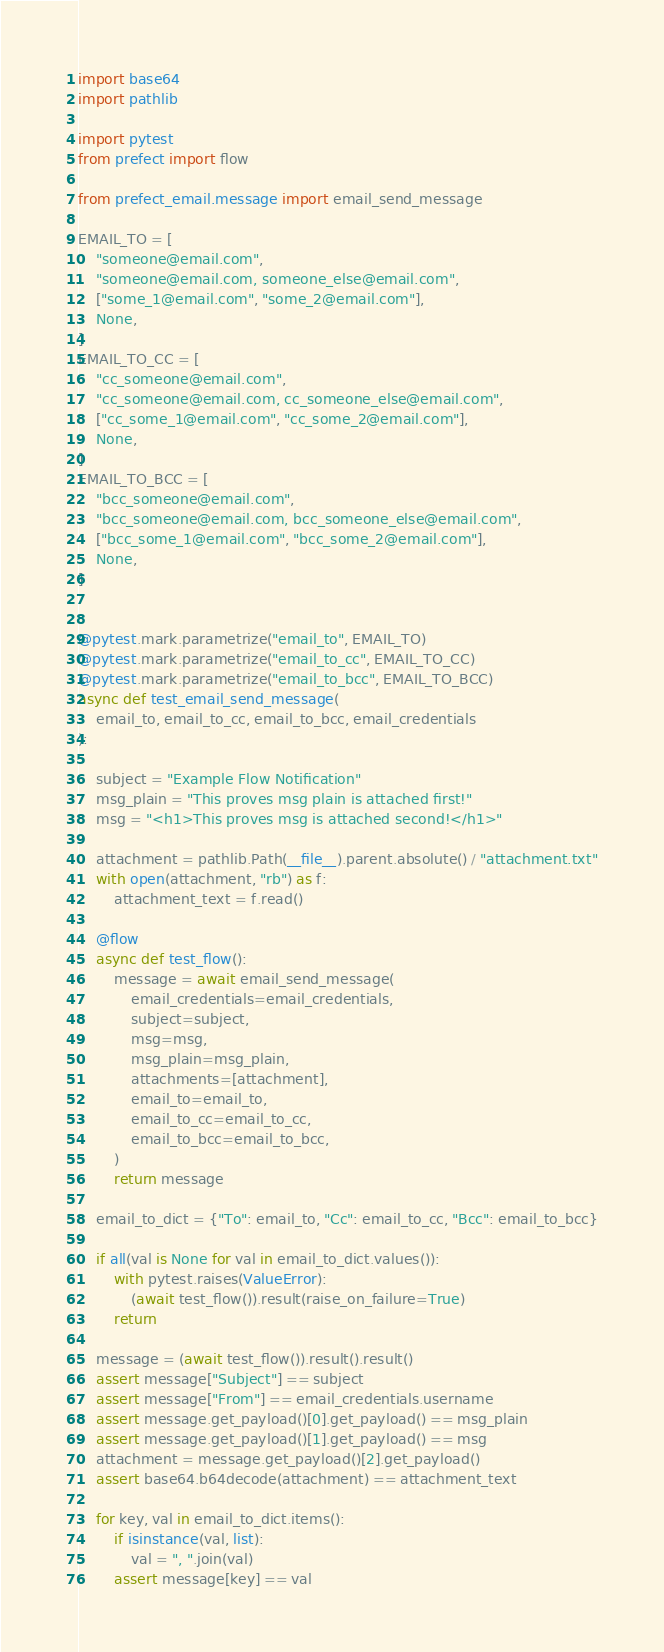Convert code to text. <code><loc_0><loc_0><loc_500><loc_500><_Python_>import base64
import pathlib

import pytest
from prefect import flow

from prefect_email.message import email_send_message

EMAIL_TO = [
    "someone@email.com",
    "someone@email.com, someone_else@email.com",
    ["some_1@email.com", "some_2@email.com"],
    None,
]
EMAIL_TO_CC = [
    "cc_someone@email.com",
    "cc_someone@email.com, cc_someone_else@email.com",
    ["cc_some_1@email.com", "cc_some_2@email.com"],
    None,
]
EMAIL_TO_BCC = [
    "bcc_someone@email.com",
    "bcc_someone@email.com, bcc_someone_else@email.com",
    ["bcc_some_1@email.com", "bcc_some_2@email.com"],
    None,
]


@pytest.mark.parametrize("email_to", EMAIL_TO)
@pytest.mark.parametrize("email_to_cc", EMAIL_TO_CC)
@pytest.mark.parametrize("email_to_bcc", EMAIL_TO_BCC)
async def test_email_send_message(
    email_to, email_to_cc, email_to_bcc, email_credentials
):

    subject = "Example Flow Notification"
    msg_plain = "This proves msg plain is attached first!"
    msg = "<h1>This proves msg is attached second!</h1>"

    attachment = pathlib.Path(__file__).parent.absolute() / "attachment.txt"
    with open(attachment, "rb") as f:
        attachment_text = f.read()

    @flow
    async def test_flow():
        message = await email_send_message(
            email_credentials=email_credentials,
            subject=subject,
            msg=msg,
            msg_plain=msg_plain,
            attachments=[attachment],
            email_to=email_to,
            email_to_cc=email_to_cc,
            email_to_bcc=email_to_bcc,
        )
        return message

    email_to_dict = {"To": email_to, "Cc": email_to_cc, "Bcc": email_to_bcc}

    if all(val is None for val in email_to_dict.values()):
        with pytest.raises(ValueError):
            (await test_flow()).result(raise_on_failure=True)
        return

    message = (await test_flow()).result().result()
    assert message["Subject"] == subject
    assert message["From"] == email_credentials.username
    assert message.get_payload()[0].get_payload() == msg_plain
    assert message.get_payload()[1].get_payload() == msg
    attachment = message.get_payload()[2].get_payload()
    assert base64.b64decode(attachment) == attachment_text

    for key, val in email_to_dict.items():
        if isinstance(val, list):
            val = ", ".join(val)
        assert message[key] == val
</code> 